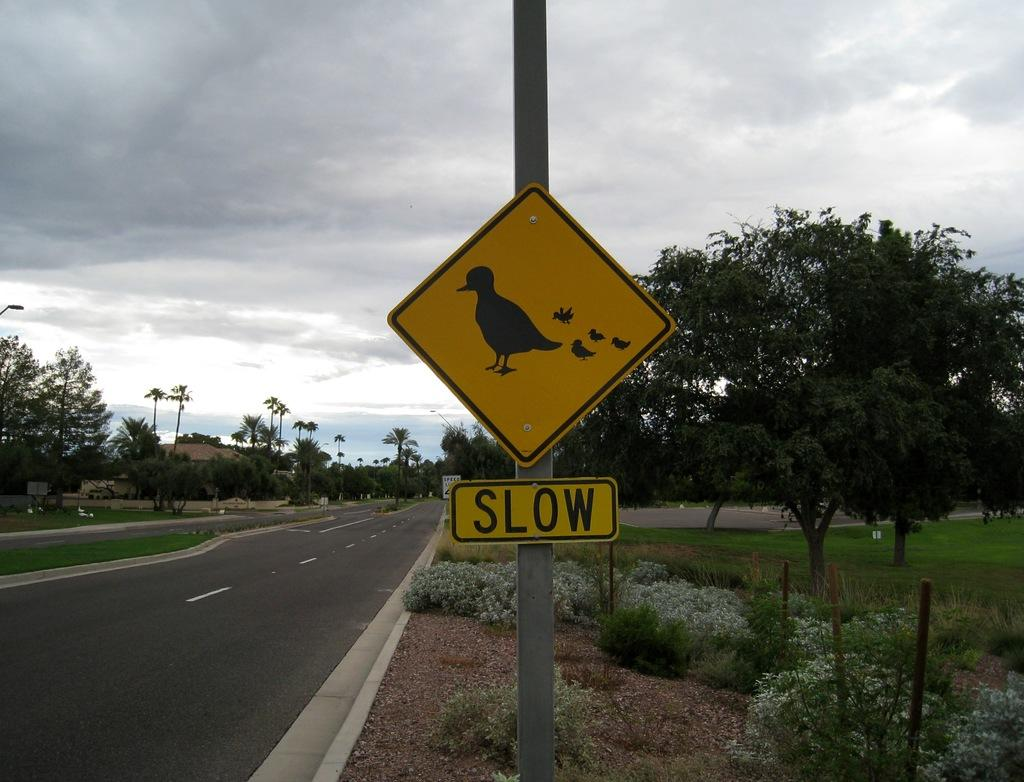<image>
Offer a succinct explanation of the picture presented. Drivers are warned to be slow for crossing ducks. 